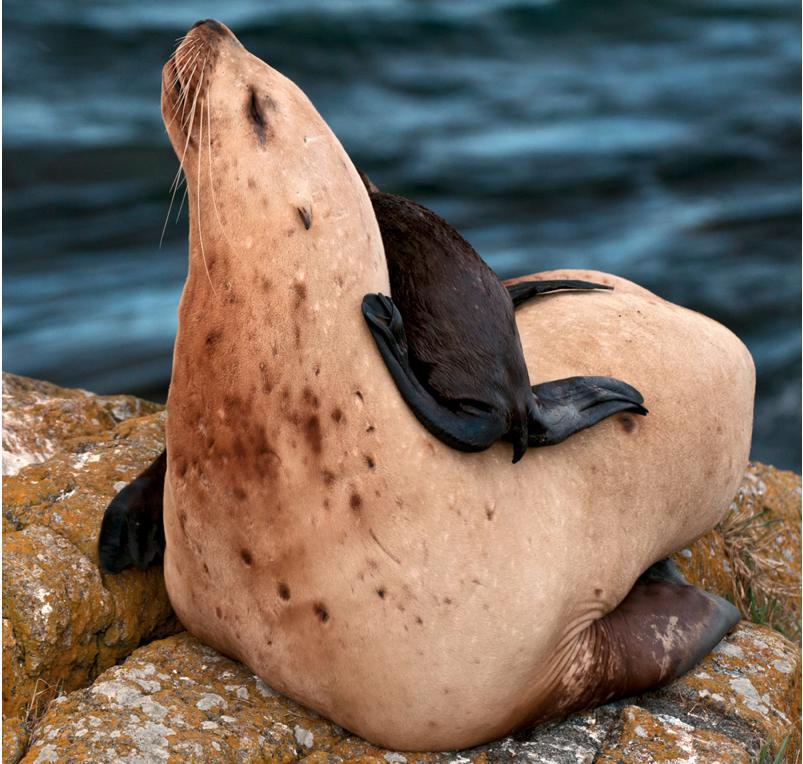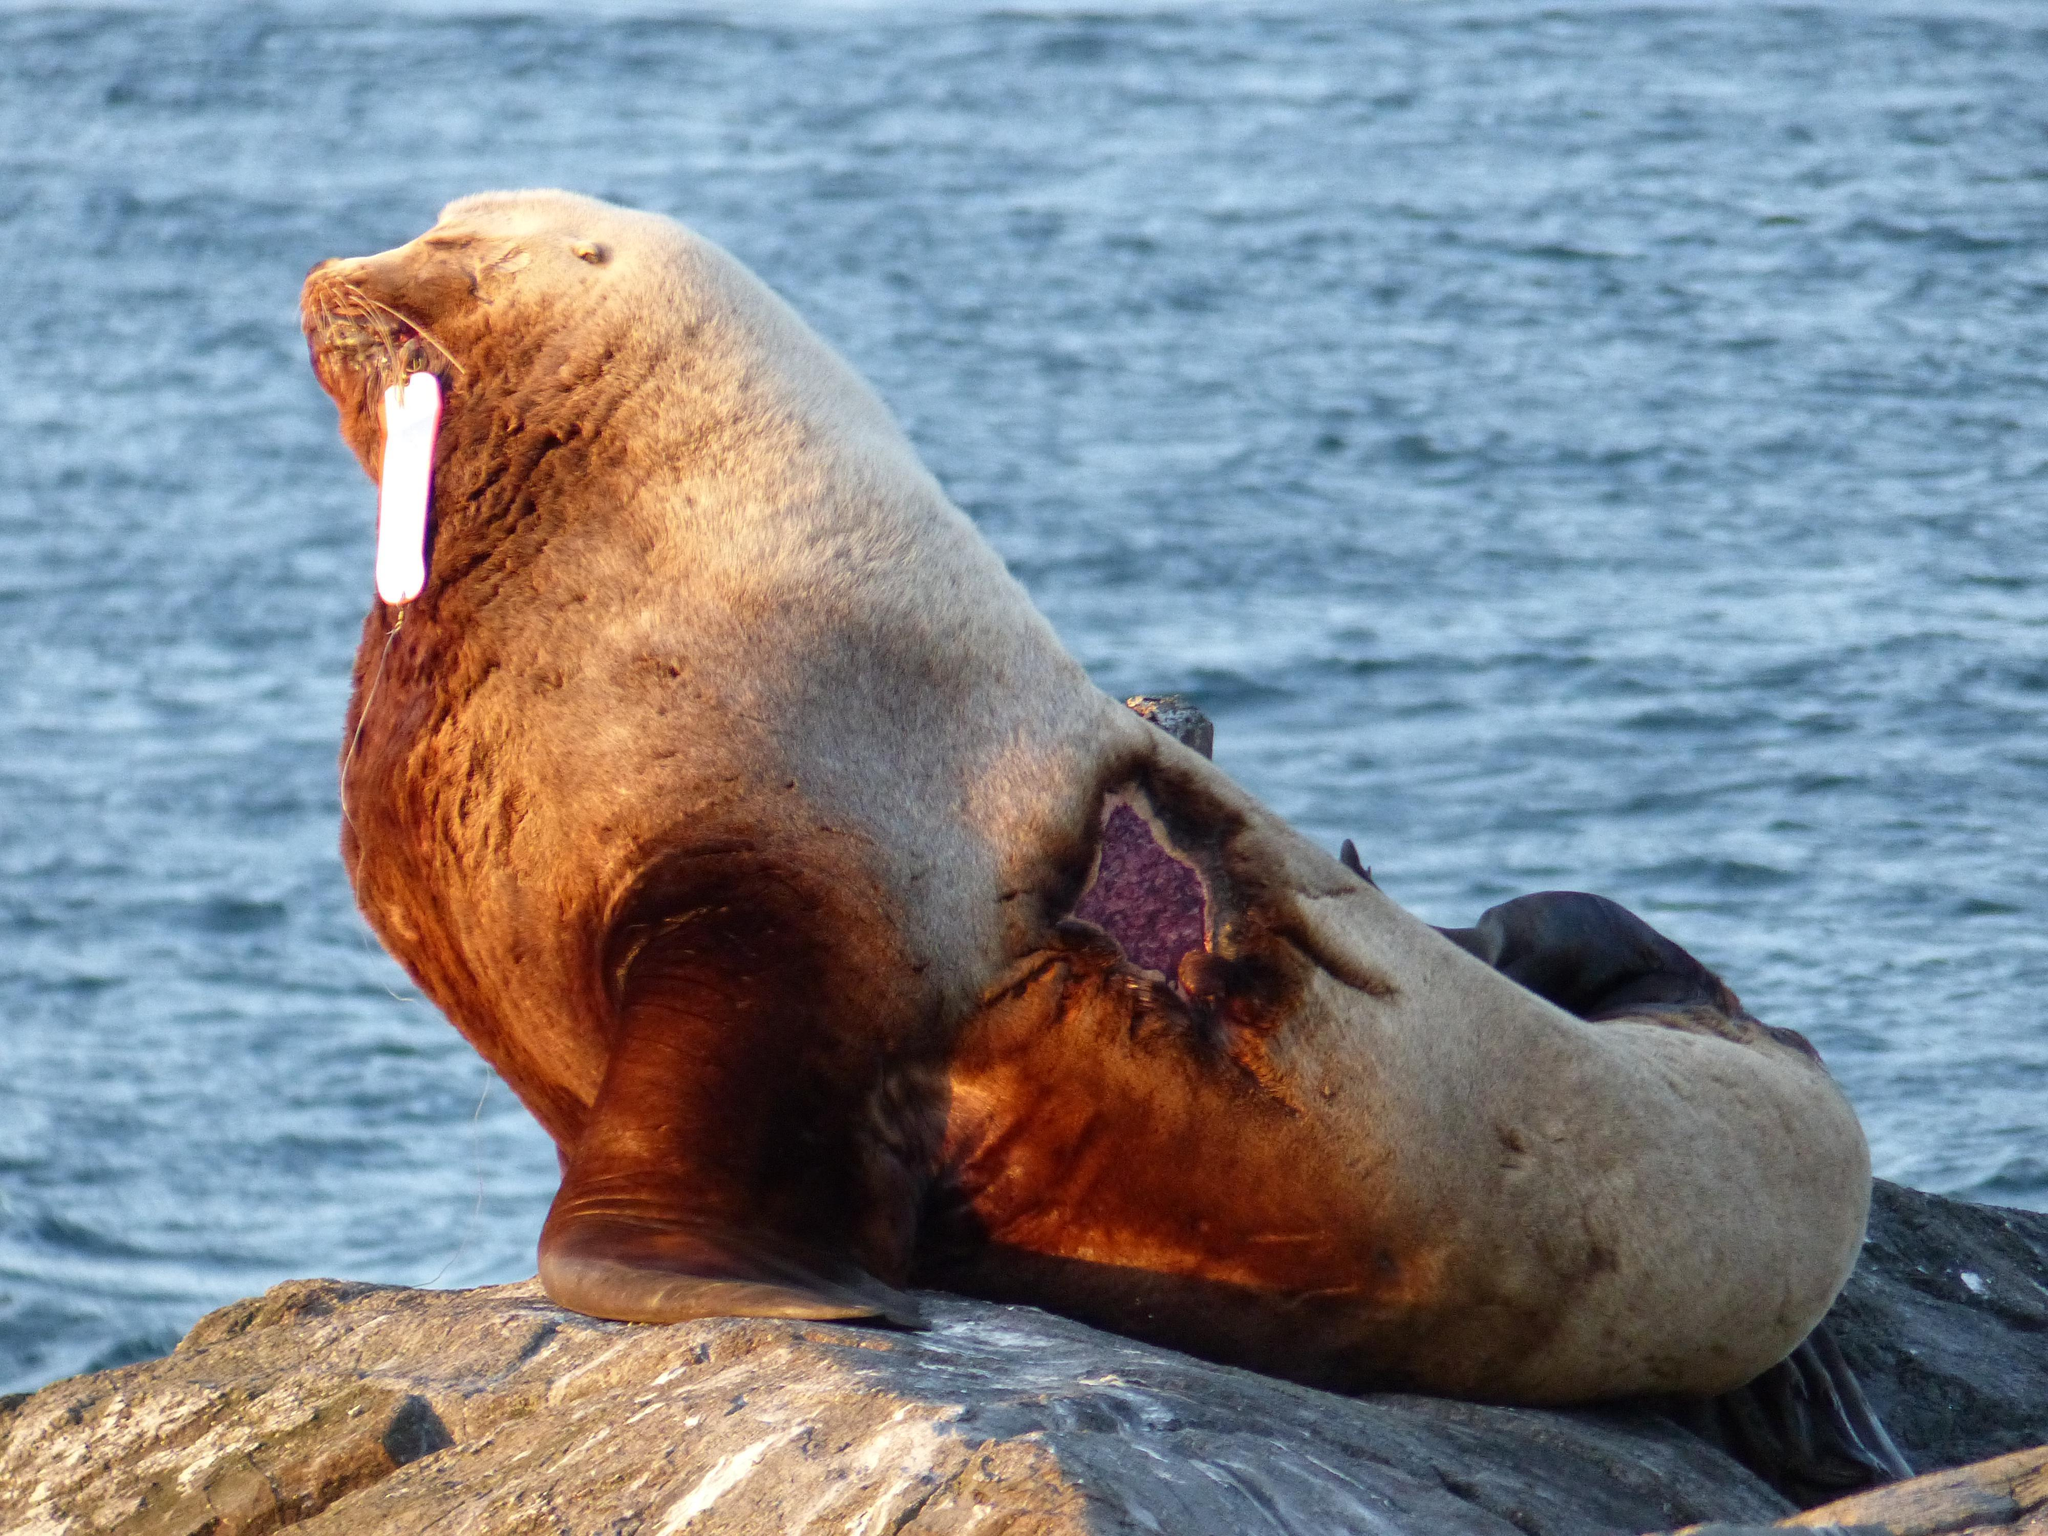The first image is the image on the left, the second image is the image on the right. Assess this claim about the two images: "At least one image includes human interaction with a seal.". Correct or not? Answer yes or no. No. 